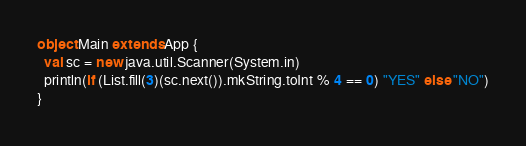Convert code to text. <code><loc_0><loc_0><loc_500><loc_500><_Scala_>object Main extends App {
  val sc = new java.util.Scanner(System.in)
  println(if (List.fill(3)(sc.next()).mkString.toInt % 4 == 0) "YES" else "NO")
}
</code> 